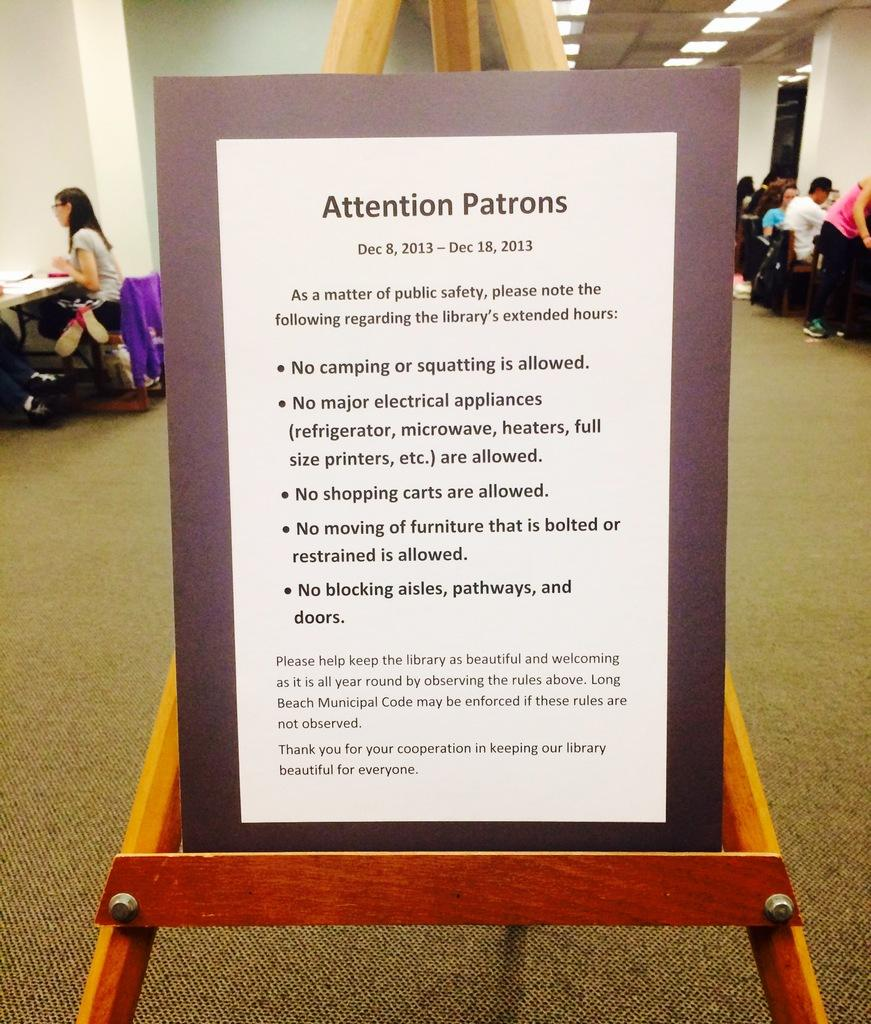What is the main object in the image? There is a board in the image. What can be seen on the board? Something is written on the board. What are the people in the image doing? There are people sitting on chairs in the image. What is on the table in the image? There are objects on a table in the image. What color is the wall in the image? The wall is white in color. Can you tell me how many people are swimming in the image? There is no swimming activity depicted in the image. What type of nose is visible on the board in the image? There is no nose present on the board or in the image. 